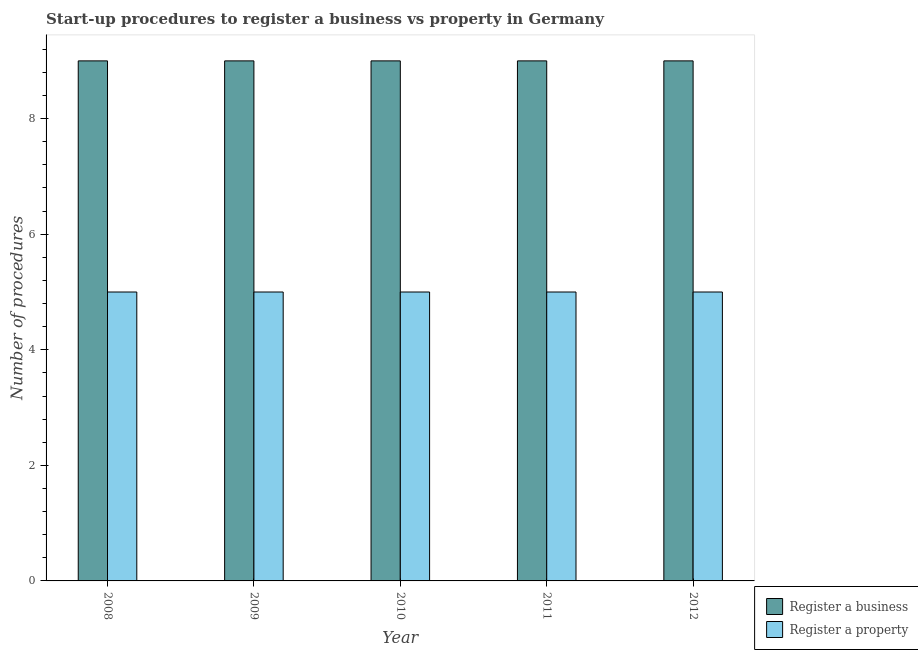Are the number of bars per tick equal to the number of legend labels?
Keep it short and to the point. Yes. Are the number of bars on each tick of the X-axis equal?
Give a very brief answer. Yes. In how many cases, is the number of bars for a given year not equal to the number of legend labels?
Your answer should be very brief. 0. What is the number of procedures to register a business in 2011?
Ensure brevity in your answer.  9. Across all years, what is the maximum number of procedures to register a property?
Your answer should be very brief. 5. Across all years, what is the minimum number of procedures to register a property?
Provide a succinct answer. 5. In which year was the number of procedures to register a business maximum?
Keep it short and to the point. 2008. What is the total number of procedures to register a property in the graph?
Give a very brief answer. 25. In the year 2012, what is the difference between the number of procedures to register a property and number of procedures to register a business?
Your response must be concise. 0. In how many years, is the number of procedures to register a business greater than 7.2?
Your answer should be very brief. 5. What is the ratio of the number of procedures to register a property in 2009 to that in 2012?
Provide a succinct answer. 1. Is the difference between the number of procedures to register a business in 2008 and 2011 greater than the difference between the number of procedures to register a property in 2008 and 2011?
Provide a succinct answer. No. What is the difference between the highest and the lowest number of procedures to register a property?
Offer a very short reply. 0. Is the sum of the number of procedures to register a property in 2010 and 2012 greater than the maximum number of procedures to register a business across all years?
Make the answer very short. Yes. What does the 2nd bar from the left in 2008 represents?
Ensure brevity in your answer.  Register a property. What does the 1st bar from the right in 2009 represents?
Give a very brief answer. Register a property. Are all the bars in the graph horizontal?
Offer a very short reply. No. How many years are there in the graph?
Your answer should be very brief. 5. What is the difference between two consecutive major ticks on the Y-axis?
Keep it short and to the point. 2. Are the values on the major ticks of Y-axis written in scientific E-notation?
Provide a short and direct response. No. Does the graph contain grids?
Ensure brevity in your answer.  No. Where does the legend appear in the graph?
Keep it short and to the point. Bottom right. How many legend labels are there?
Ensure brevity in your answer.  2. How are the legend labels stacked?
Offer a terse response. Vertical. What is the title of the graph?
Keep it short and to the point. Start-up procedures to register a business vs property in Germany. Does "Foreign liabilities" appear as one of the legend labels in the graph?
Keep it short and to the point. No. What is the label or title of the X-axis?
Offer a terse response. Year. What is the label or title of the Y-axis?
Your response must be concise. Number of procedures. What is the Number of procedures in Register a business in 2008?
Make the answer very short. 9. What is the Number of procedures in Register a property in 2009?
Offer a very short reply. 5. What is the Number of procedures in Register a property in 2011?
Your answer should be compact. 5. Across all years, what is the maximum Number of procedures of Register a business?
Give a very brief answer. 9. Across all years, what is the maximum Number of procedures of Register a property?
Offer a terse response. 5. Across all years, what is the minimum Number of procedures of Register a business?
Offer a very short reply. 9. Across all years, what is the minimum Number of procedures in Register a property?
Provide a succinct answer. 5. What is the total Number of procedures of Register a business in the graph?
Your response must be concise. 45. What is the difference between the Number of procedures of Register a property in 2008 and that in 2009?
Provide a short and direct response. 0. What is the difference between the Number of procedures in Register a property in 2008 and that in 2010?
Ensure brevity in your answer.  0. What is the difference between the Number of procedures in Register a property in 2008 and that in 2011?
Give a very brief answer. 0. What is the difference between the Number of procedures of Register a business in 2008 and that in 2012?
Keep it short and to the point. 0. What is the difference between the Number of procedures in Register a property in 2008 and that in 2012?
Make the answer very short. 0. What is the difference between the Number of procedures of Register a business in 2009 and that in 2012?
Provide a succinct answer. 0. What is the difference between the Number of procedures in Register a property in 2009 and that in 2012?
Your answer should be compact. 0. What is the difference between the Number of procedures in Register a business in 2010 and that in 2012?
Provide a succinct answer. 0. What is the difference between the Number of procedures in Register a property in 2011 and that in 2012?
Provide a short and direct response. 0. What is the difference between the Number of procedures of Register a business in 2008 and the Number of procedures of Register a property in 2009?
Your answer should be very brief. 4. What is the difference between the Number of procedures in Register a business in 2008 and the Number of procedures in Register a property in 2011?
Give a very brief answer. 4. What is the difference between the Number of procedures in Register a business in 2009 and the Number of procedures in Register a property in 2010?
Your answer should be very brief. 4. What is the difference between the Number of procedures in Register a business in 2009 and the Number of procedures in Register a property in 2012?
Your answer should be compact. 4. What is the difference between the Number of procedures of Register a business in 2010 and the Number of procedures of Register a property in 2012?
Provide a succinct answer. 4. In the year 2010, what is the difference between the Number of procedures of Register a business and Number of procedures of Register a property?
Ensure brevity in your answer.  4. In the year 2011, what is the difference between the Number of procedures in Register a business and Number of procedures in Register a property?
Offer a very short reply. 4. In the year 2012, what is the difference between the Number of procedures in Register a business and Number of procedures in Register a property?
Your answer should be very brief. 4. What is the ratio of the Number of procedures in Register a business in 2008 to that in 2009?
Your answer should be compact. 1. What is the ratio of the Number of procedures of Register a business in 2008 to that in 2010?
Provide a short and direct response. 1. What is the ratio of the Number of procedures in Register a property in 2008 to that in 2010?
Your response must be concise. 1. What is the ratio of the Number of procedures of Register a business in 2008 to that in 2011?
Ensure brevity in your answer.  1. What is the ratio of the Number of procedures of Register a property in 2009 to that in 2011?
Your answer should be very brief. 1. What is the ratio of the Number of procedures in Register a property in 2009 to that in 2012?
Your response must be concise. 1. What is the ratio of the Number of procedures of Register a business in 2010 to that in 2011?
Keep it short and to the point. 1. What is the ratio of the Number of procedures of Register a property in 2010 to that in 2011?
Your response must be concise. 1. What is the ratio of the Number of procedures of Register a property in 2010 to that in 2012?
Give a very brief answer. 1. What is the ratio of the Number of procedures in Register a business in 2011 to that in 2012?
Provide a short and direct response. 1. What is the difference between the highest and the second highest Number of procedures in Register a business?
Give a very brief answer. 0. What is the difference between the highest and the lowest Number of procedures in Register a business?
Provide a succinct answer. 0. 